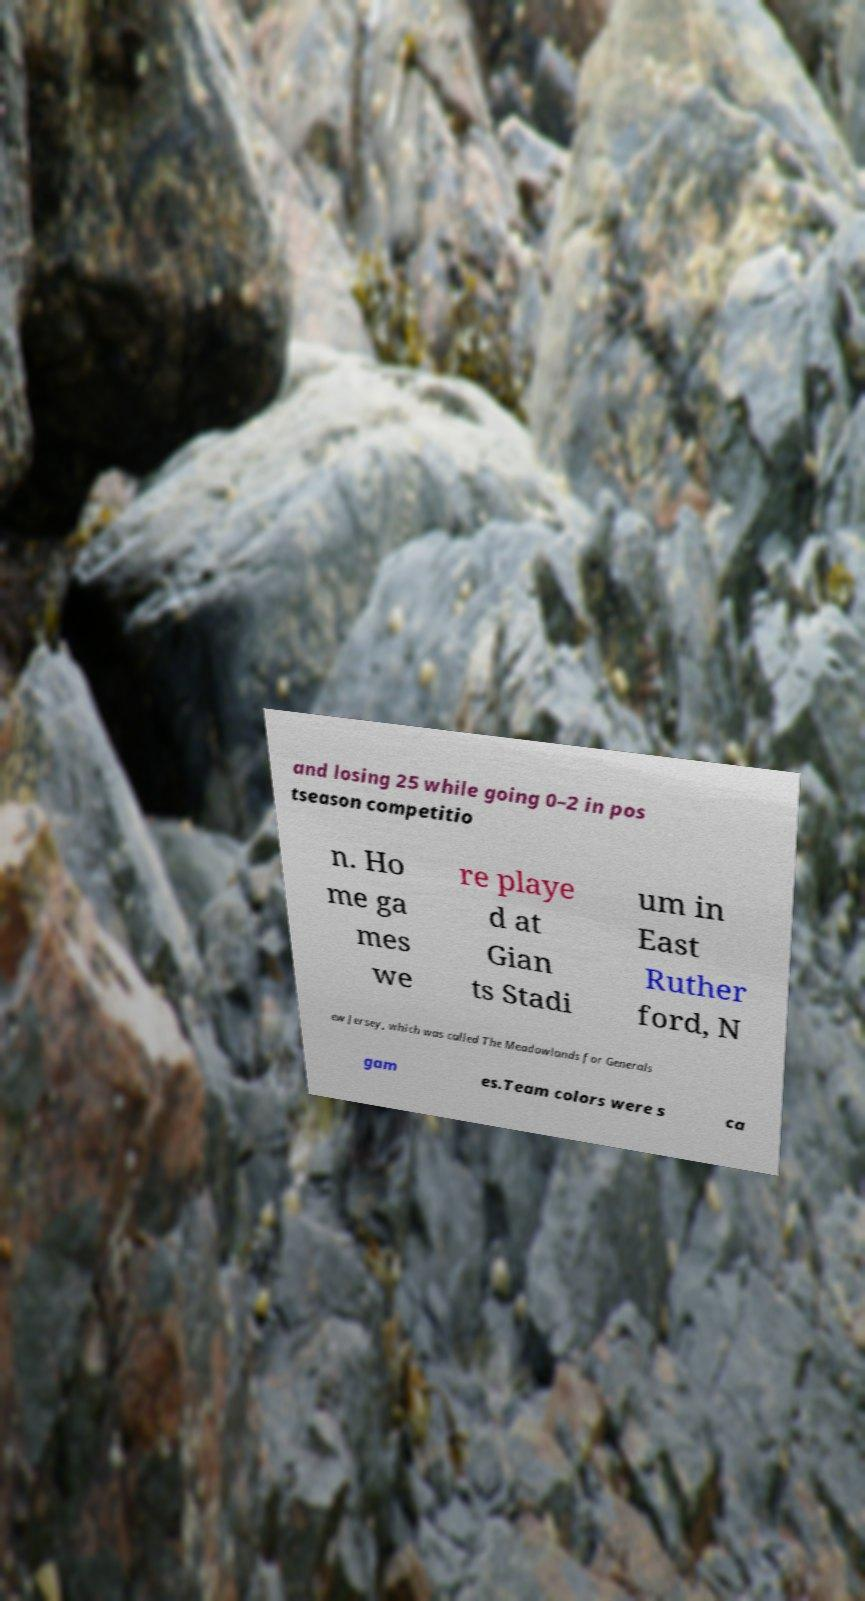Could you assist in decoding the text presented in this image and type it out clearly? and losing 25 while going 0–2 in pos tseason competitio n. Ho me ga mes we re playe d at Gian ts Stadi um in East Ruther ford, N ew Jersey, which was called The Meadowlands for Generals gam es.Team colors were s ca 